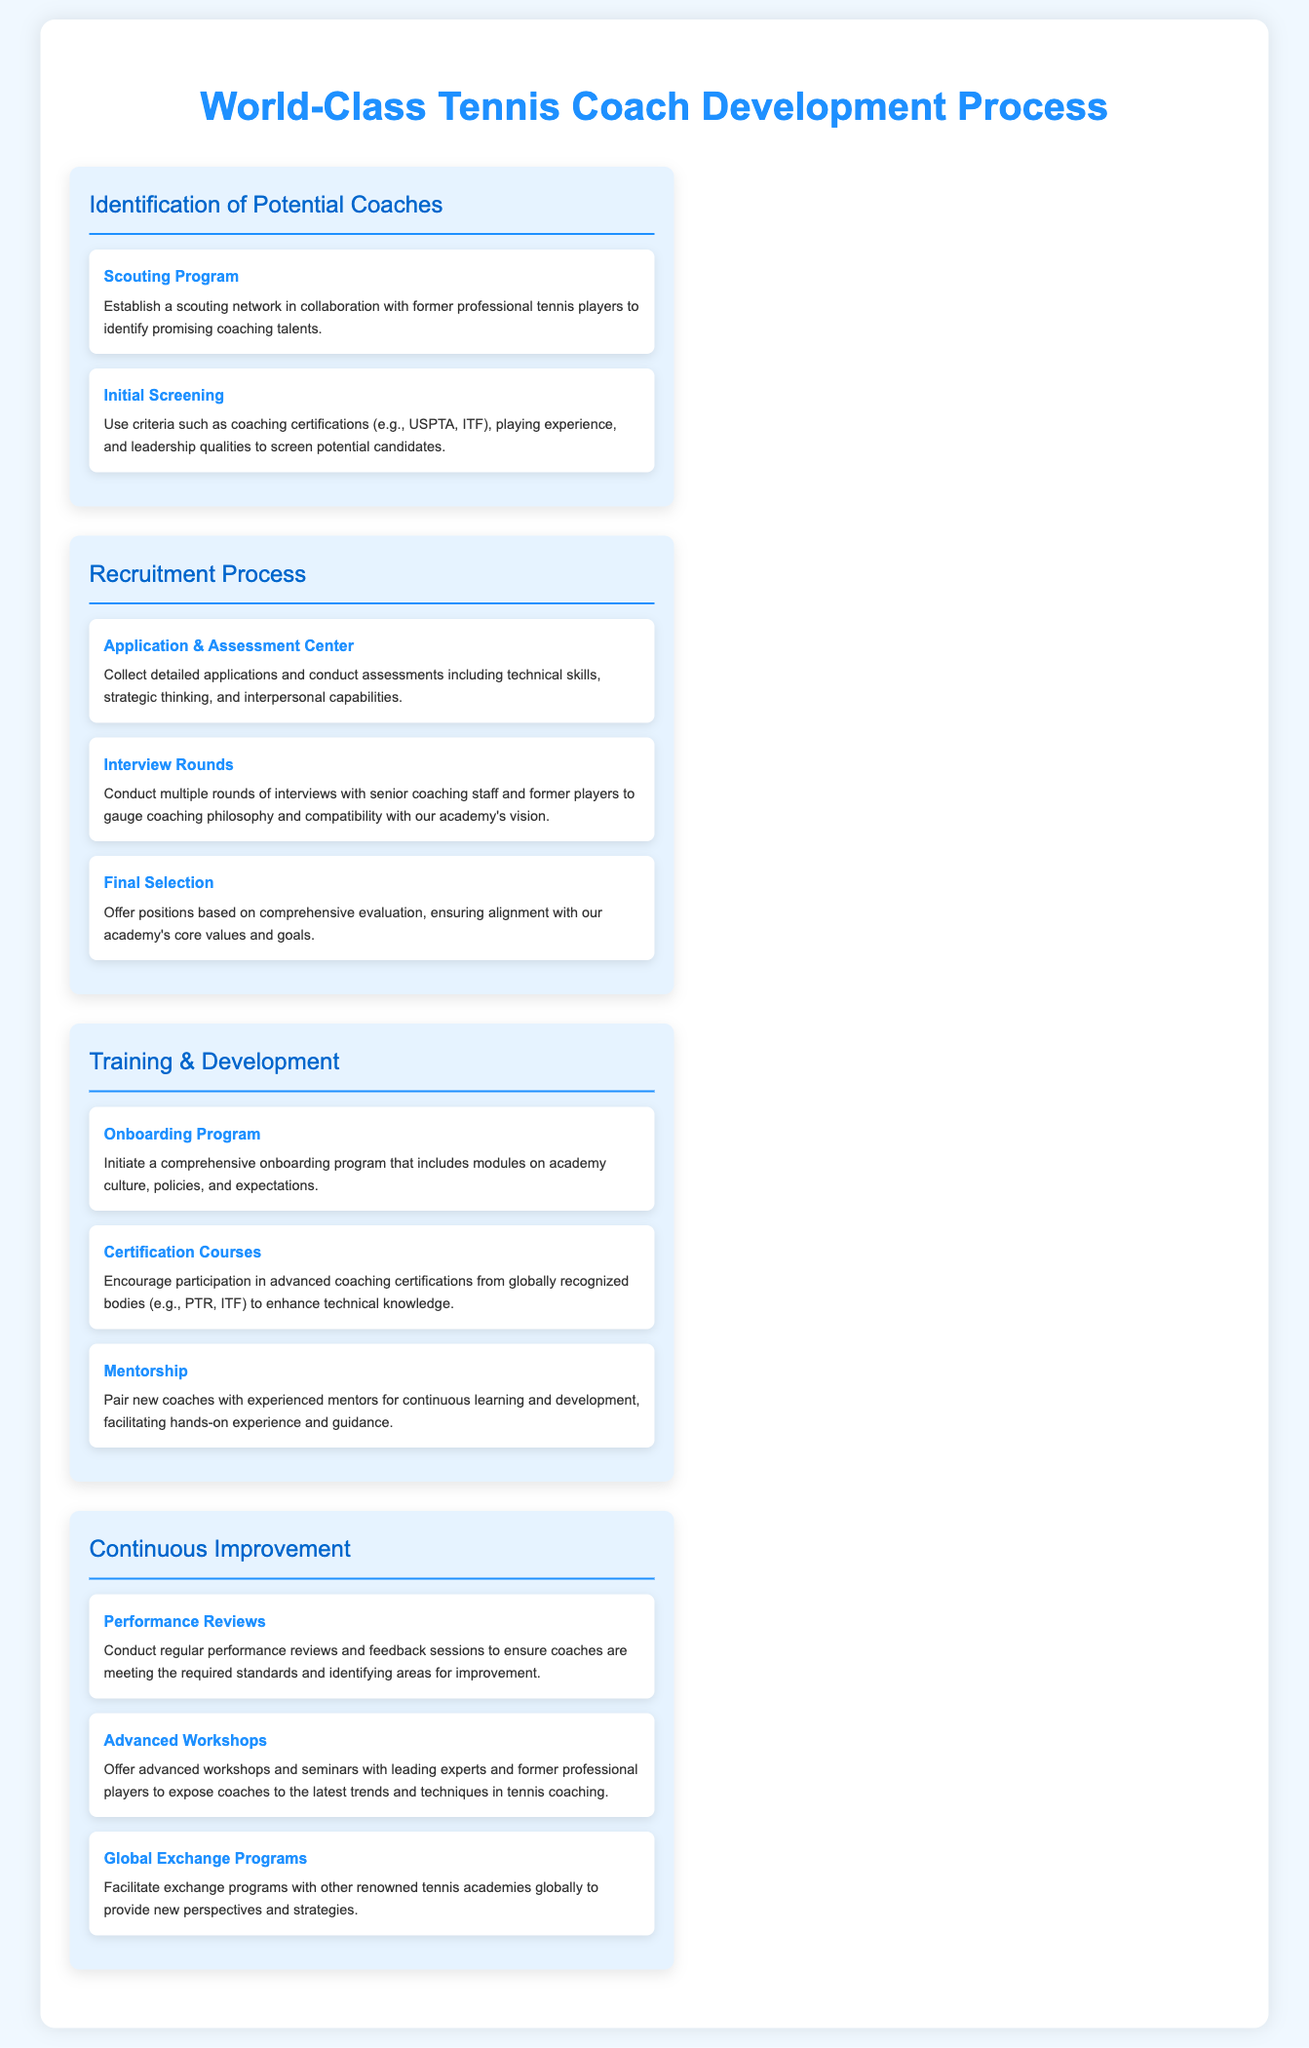What is the first step in the coach development process? The first step is identifying potential coaches through a scouting program and initial screening.
Answer: Scouting Program How many interview rounds are conducted in the recruitment process? The recruitment process includes multiple rounds of interviews with senior coaching staff and former players.
Answer: Multiple What does the onboarding program include? The onboarding program includes modules on academy culture, policies, and expectations.
Answer: Academy culture, policies, and expectations What type of workshops are provided for continuous improvement? Advanced workshops and seminars are offered with leading experts and former professional players.
Answer: Advanced workshops What is paired with new coaches for development? New coaches are paired with experienced mentors for continuous learning and development.
Answer: Experienced mentors Which organization’s certifications are encouraged during training? Advanced coaching certifications from globally recognized bodies such as PTR or ITF are encouraged.
Answer: PTR, ITF What does the final selection offer? The final selection offers positions based on comprehensive evaluation and alignment with core values.
Answer: Positions based on comprehensive evaluation What type of programs facilitate global perspectives? Global exchange programs with other renowned tennis academies are facilitated.
Answer: Global exchange programs 